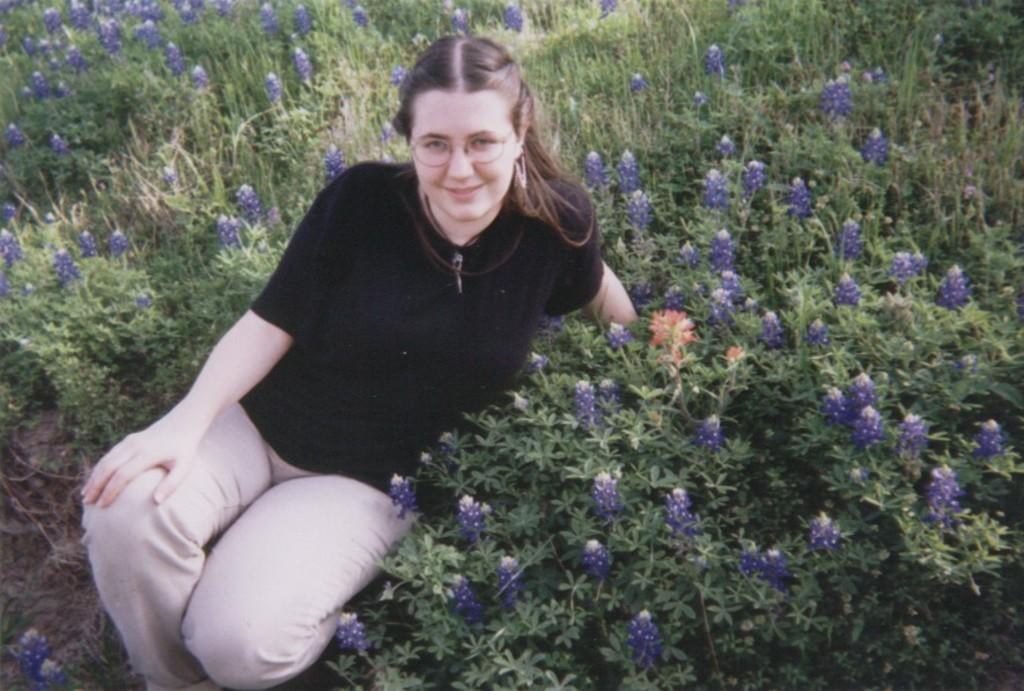Who is present in the image? There is a woman in the image. What is the woman wearing? The woman is wearing spectacles. What is the woman's facial expression? The woman is smiling. What can be seen in the background of the image? There are plants with flowers in the background of the image. What type of reward can be seen on the woman's bed in the image? There is no bed or reward present in the image; it only features a woman with plants with flowers in the background. 